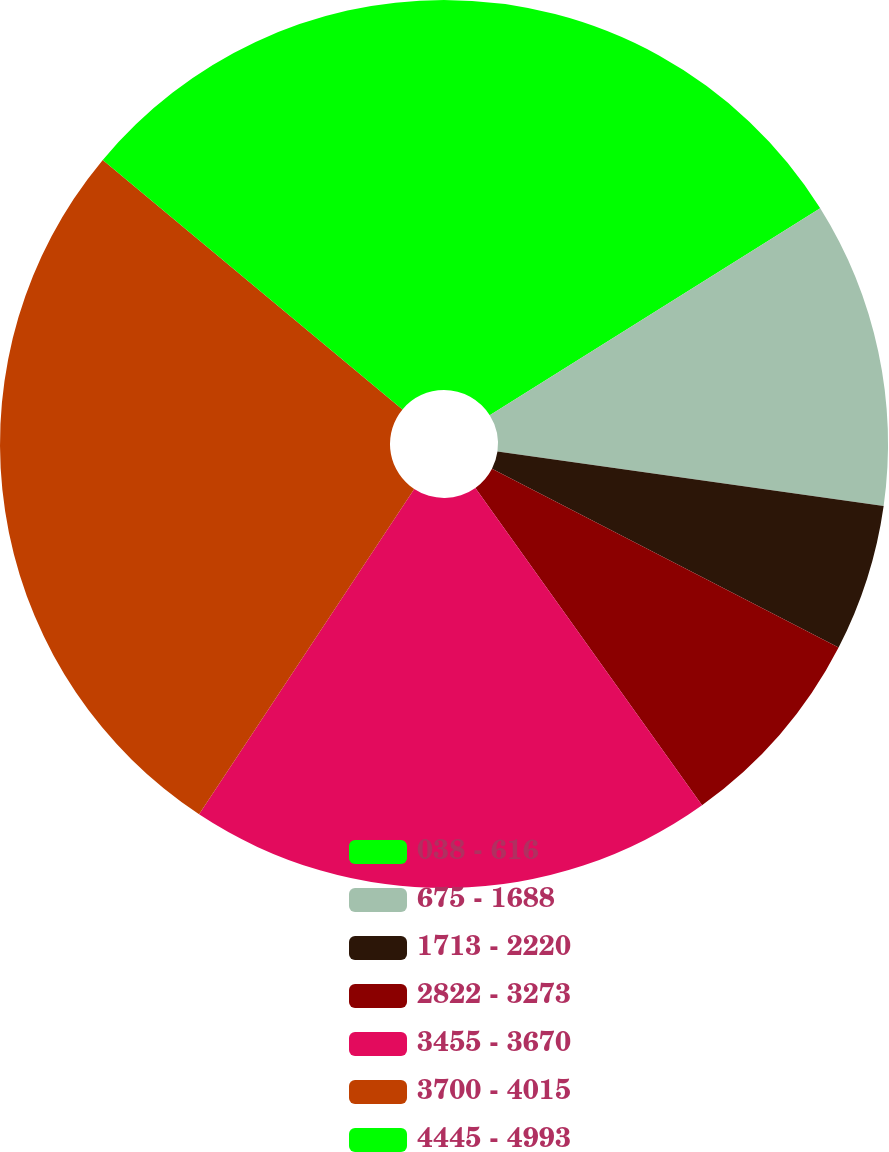<chart> <loc_0><loc_0><loc_500><loc_500><pie_chart><fcel>038 - 616<fcel>675 - 1688<fcel>1713 - 2220<fcel>2822 - 3273<fcel>3455 - 3670<fcel>3700 - 4015<fcel>4445 - 4993<nl><fcel>16.09%<fcel>11.14%<fcel>5.35%<fcel>7.55%<fcel>19.17%<fcel>26.75%<fcel>13.95%<nl></chart> 